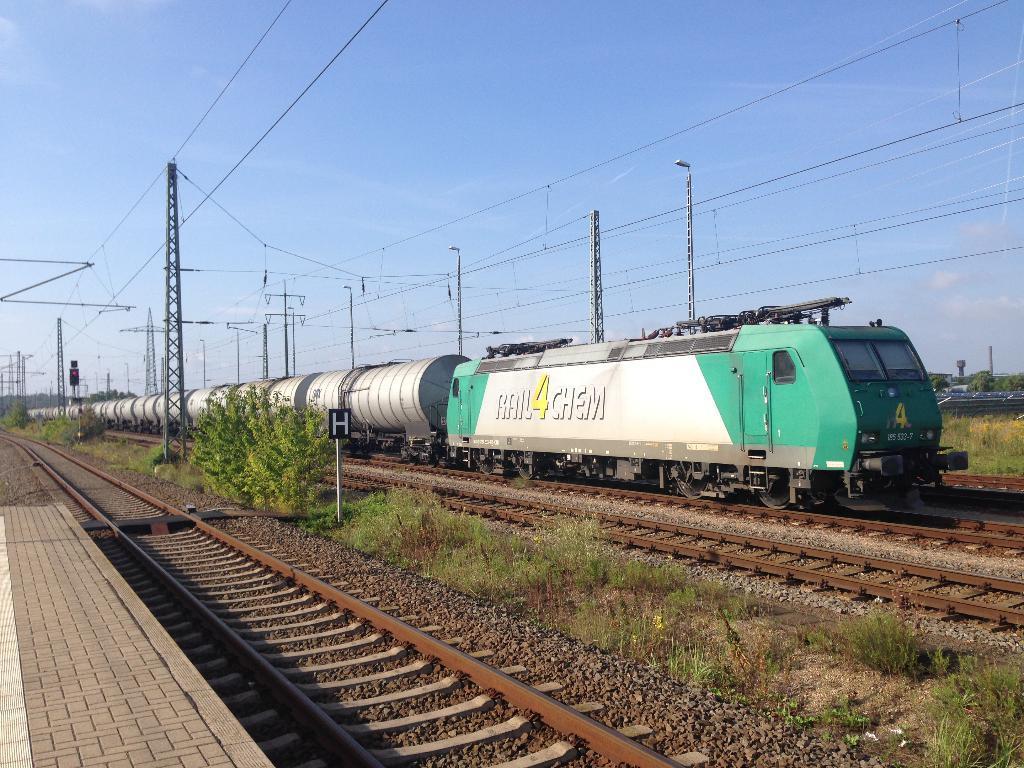Can you describe this image briefly? In the picture we can see a railway track with a train on it and besides, we can see some tracks and some plants and grass and some tracks beside it with a platform and in the background we can see some poles with wires and sky with clouds. 